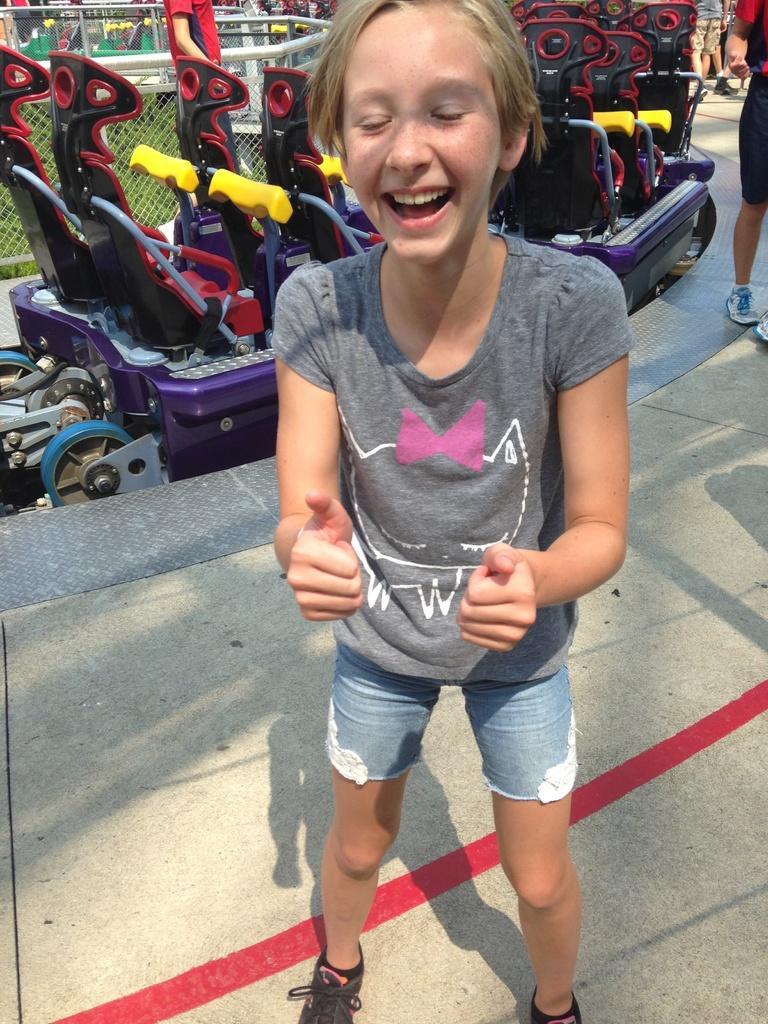Please provide a concise description of this image. In the center of the image we can see a person is standing and laughing. In the background of the image we can see the fun rides and some persons, mesh. At the bottom of the image we can see the floor. 